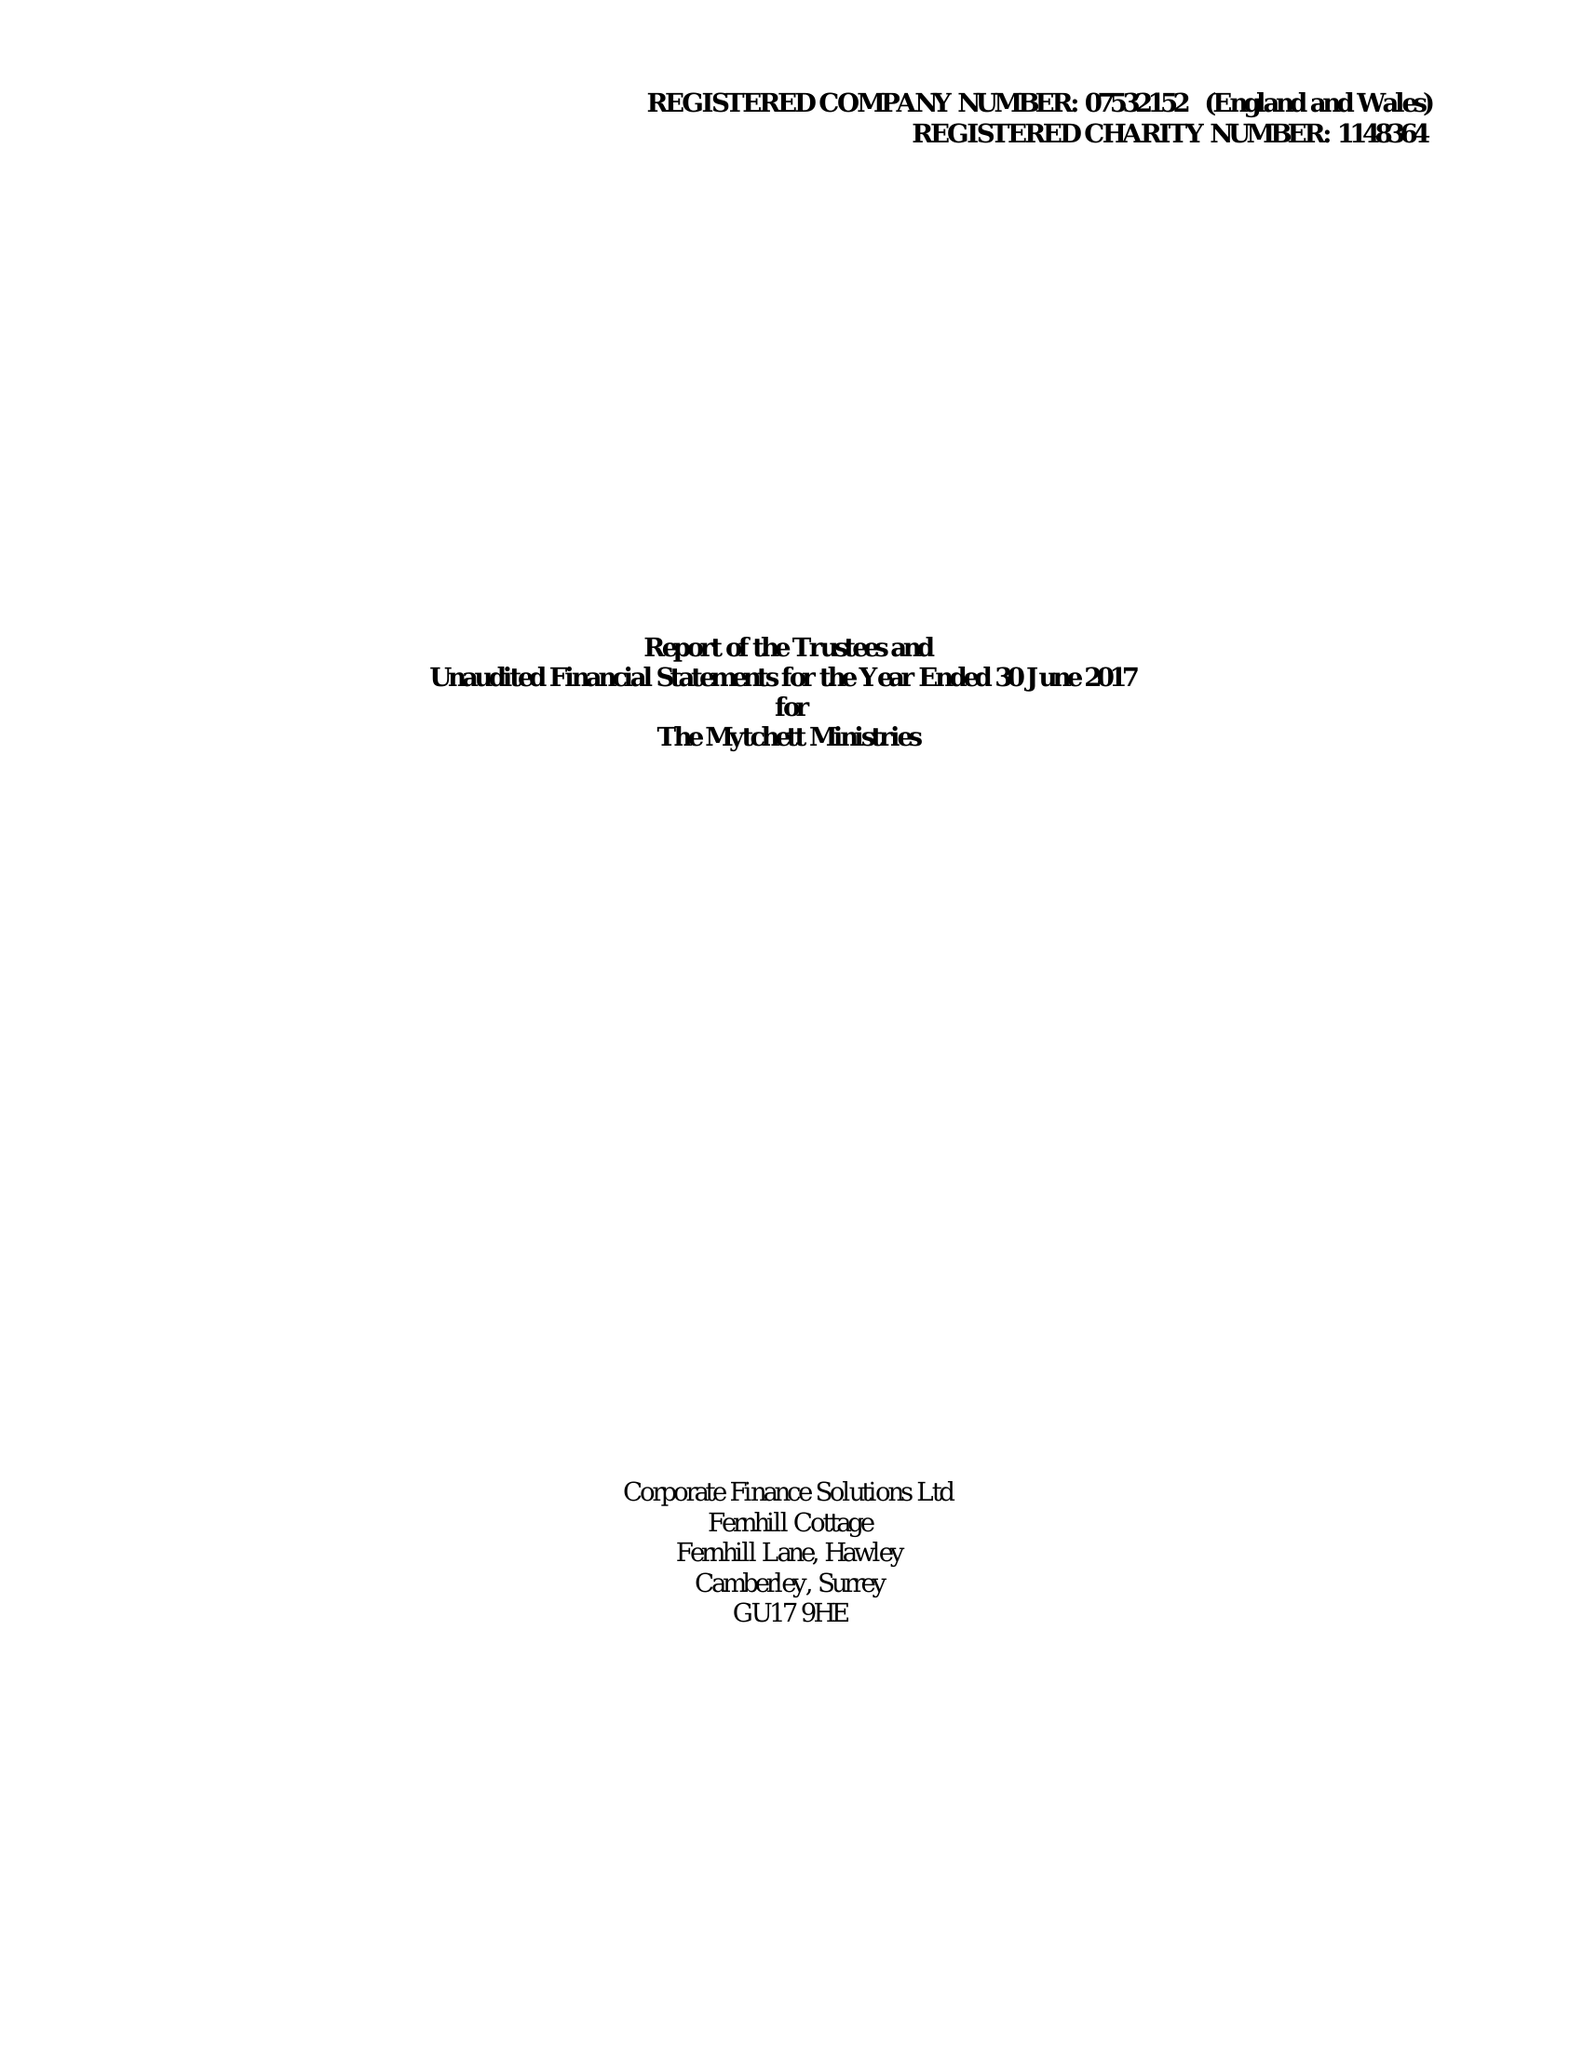What is the value for the income_annually_in_british_pounds?
Answer the question using a single word or phrase. 83758.00 